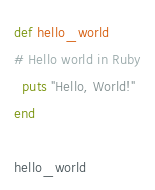<code> <loc_0><loc_0><loc_500><loc_500><_Ruby_>def hello_world
# Hello world in Ruby
  puts "Hello, World!"
end

hello_world
</code> 